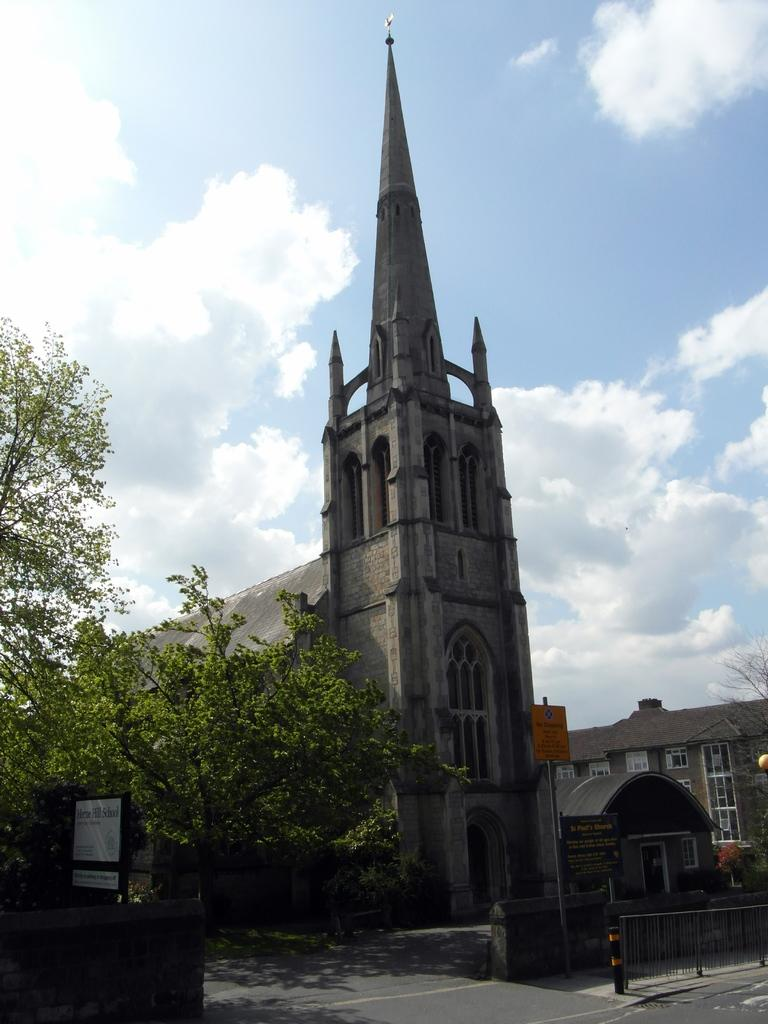What type of building can be seen in the background of the image? There is a church in the background of the image. What is located in front of the church? There is a road in front of the church. What other structures are near the church? There are buildings beside the church. What can be seen on the left side of the image? Trees are present on the left side of the image. What is visible in the sky in the image? The sky is visible in the image, and clouds are present in the sky. What advice does the beggar give to the person in the image? There is no beggar present in the image, so no advice can be given. What thing is being held by the person in the image? There is no person holding a thing in the image; the focus is on the church and its surroundings. 